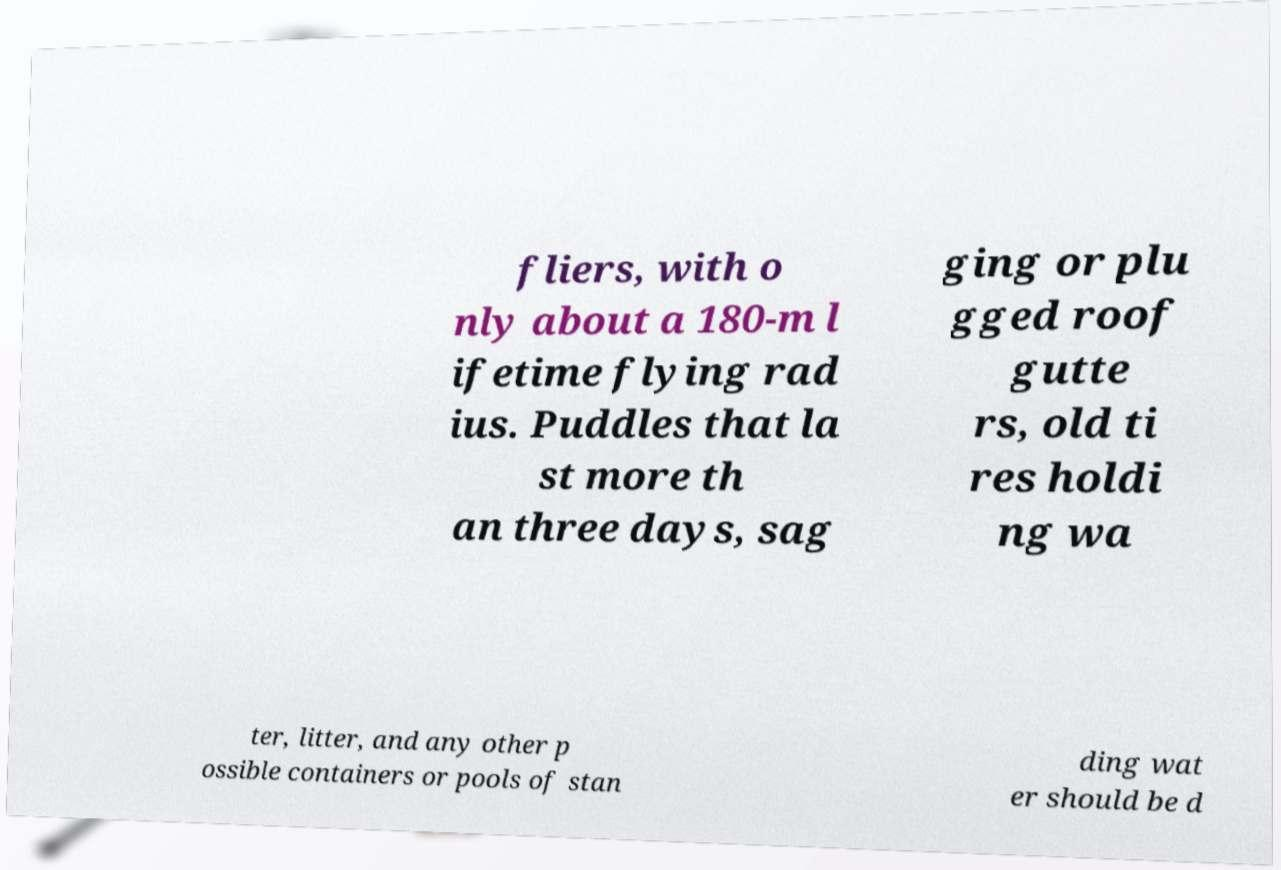There's text embedded in this image that I need extracted. Can you transcribe it verbatim? fliers, with o nly about a 180-m l ifetime flying rad ius. Puddles that la st more th an three days, sag ging or plu gged roof gutte rs, old ti res holdi ng wa ter, litter, and any other p ossible containers or pools of stan ding wat er should be d 